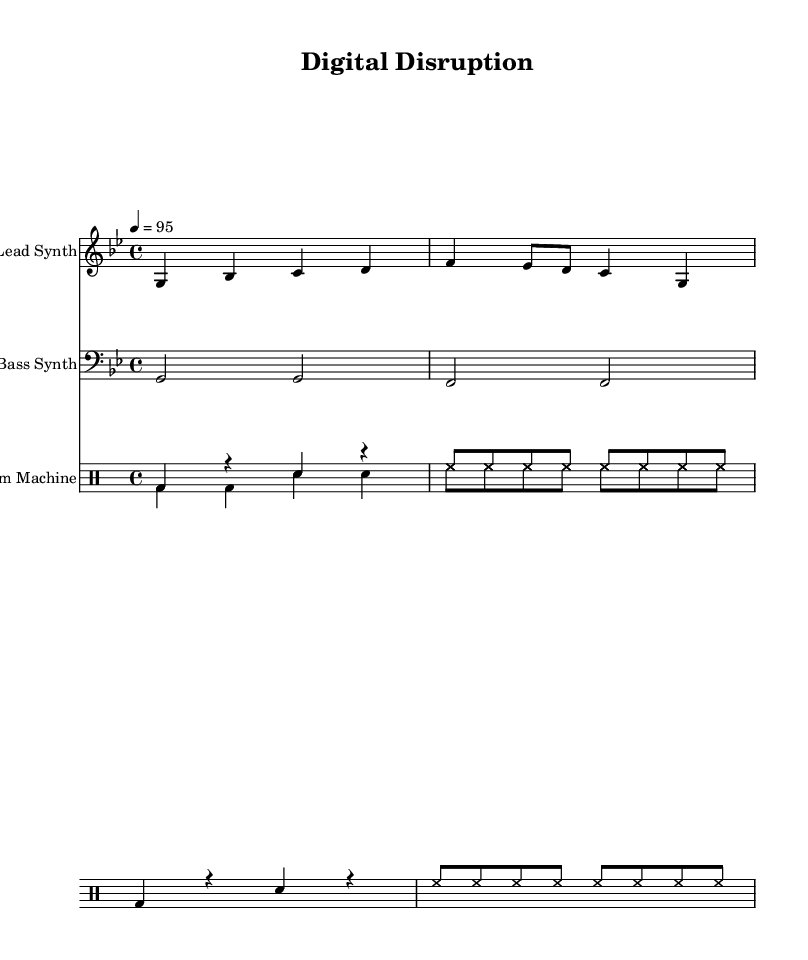What is the key signature of this music? The key signature is indicated at the beginning of the staff, showing two flats (B♭ and E♭), which corresponds to G minor.
Answer: G minor What is the time signature of this piece? The time signature is shown at the beginning of the music as 4/4, meaning there are four beats in a measure and the quarter note gets one beat.
Answer: 4/4 What is the tempo marking for this piece? The tempo marking is indicated with the number 95, meaning the piece is to be played at 95 beats per minute.
Answer: 95 How many measures are there in the lead synth part? By counting the distinct measures indicated by the bar lines, there are a total of four measures in the lead synth part.
Answer: 4 What type of drum kit is used in this music? The music uses a drum machine, as indicated by the instrument name in the score for the drum staff.
Answer: Drum Machine Are there any lyrics associated with this piece? The presence of the lyrics is indicated below the lead synth, confirming there are lyrics to the music, which are written in the lyricmode.
Answer: Yes What is the name of this track? The title of the track is specified at the top of the sheet music under the header, which reads "Digital Disruption".
Answer: Digital Disruption 